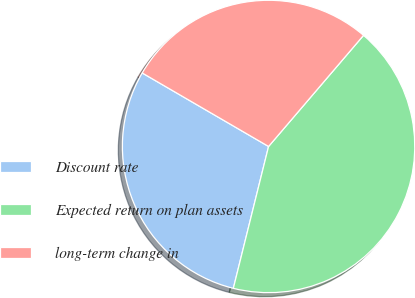Convert chart to OTSL. <chart><loc_0><loc_0><loc_500><loc_500><pie_chart><fcel>Discount rate<fcel>Expected return on plan assets<fcel>long-term change in<nl><fcel>29.51%<fcel>42.62%<fcel>27.87%<nl></chart> 